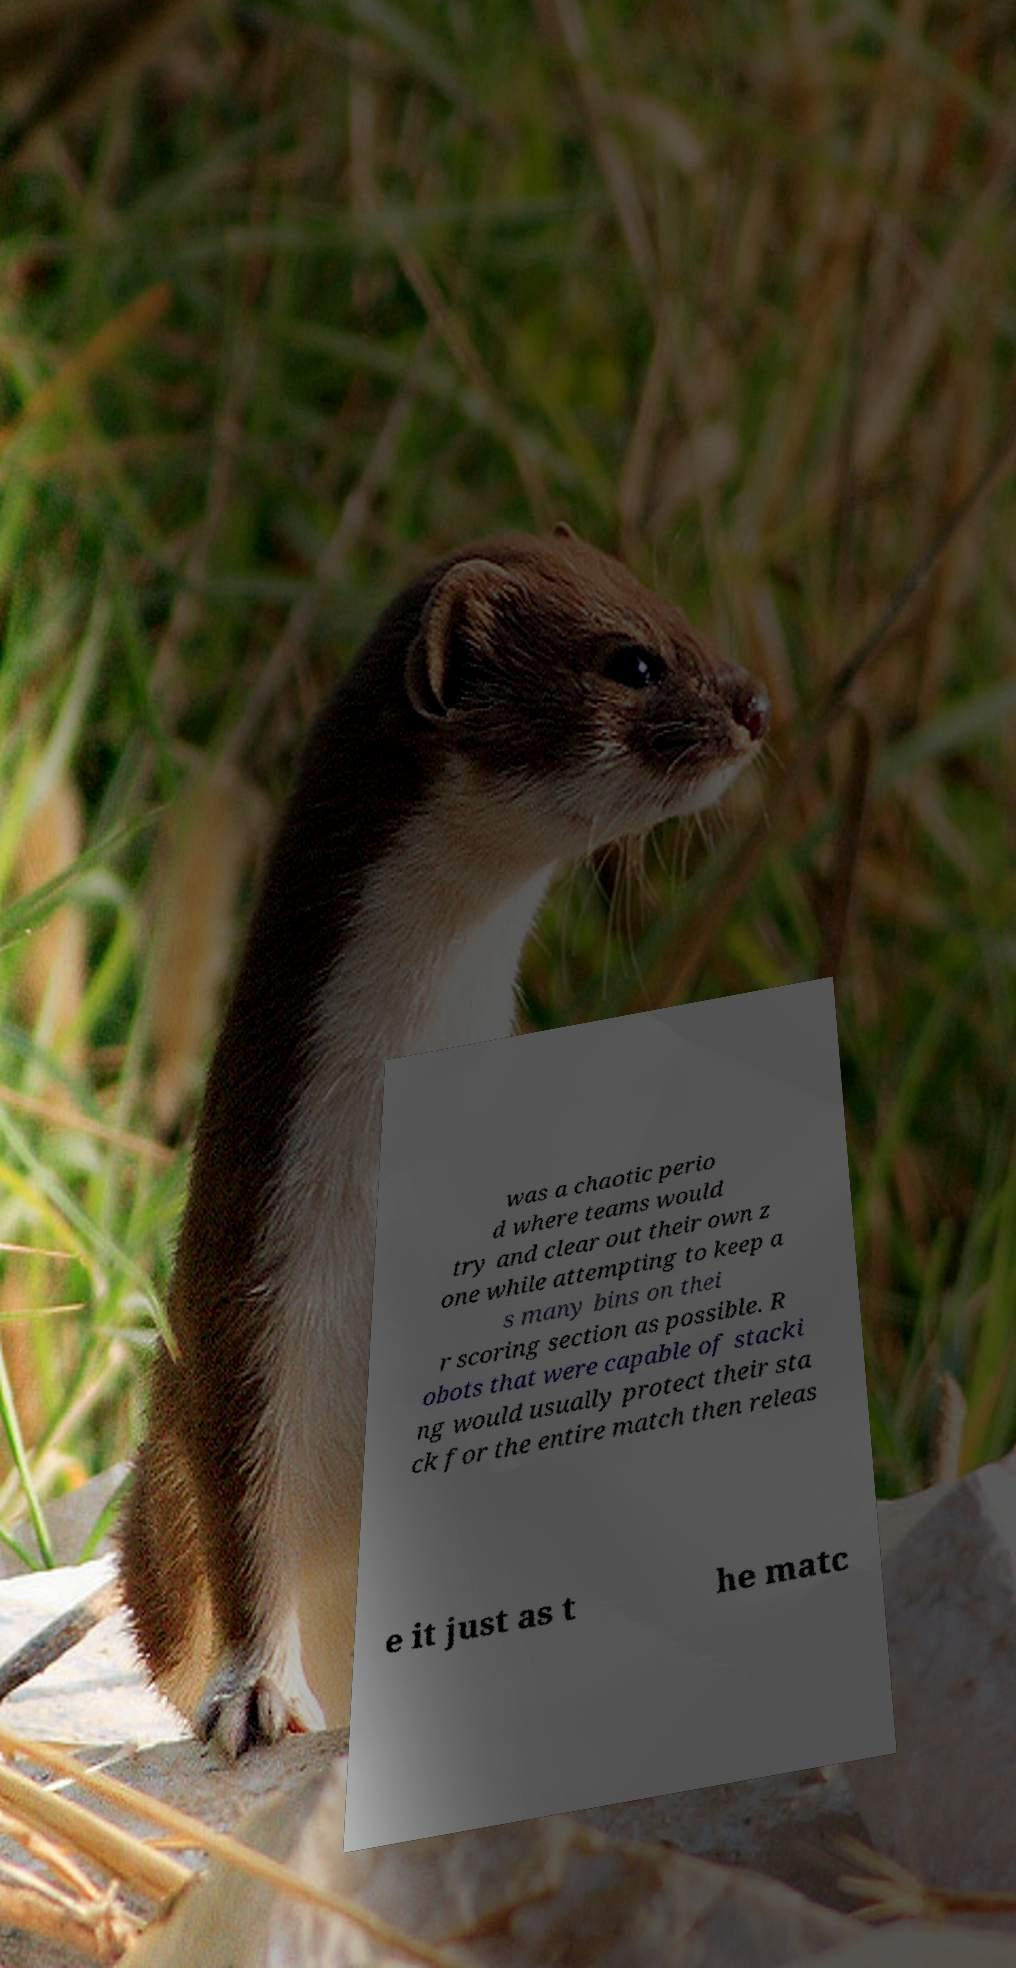Could you assist in decoding the text presented in this image and type it out clearly? was a chaotic perio d where teams would try and clear out their own z one while attempting to keep a s many bins on thei r scoring section as possible. R obots that were capable of stacki ng would usually protect their sta ck for the entire match then releas e it just as t he matc 